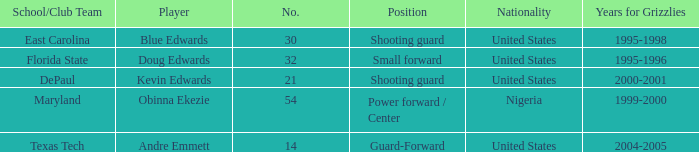When was the school/club team for grizzles was maryland 1999-2000. 